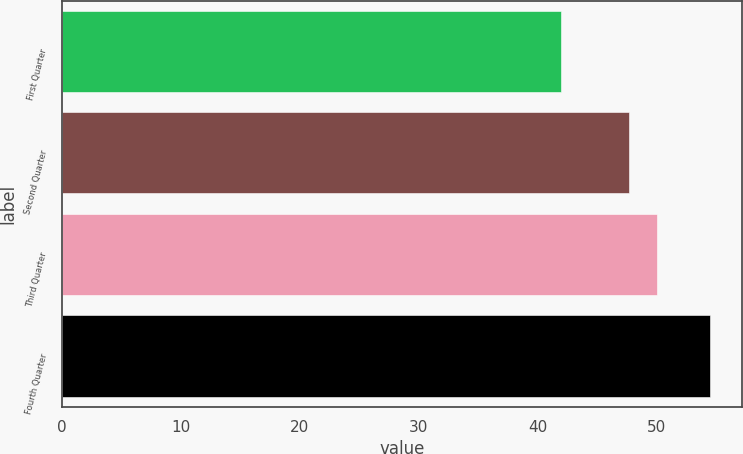Convert chart. <chart><loc_0><loc_0><loc_500><loc_500><bar_chart><fcel>First Quarter<fcel>Second Quarter<fcel>Third Quarter<fcel>Fourth Quarter<nl><fcel>41.98<fcel>47.66<fcel>50.05<fcel>54.47<nl></chart> 